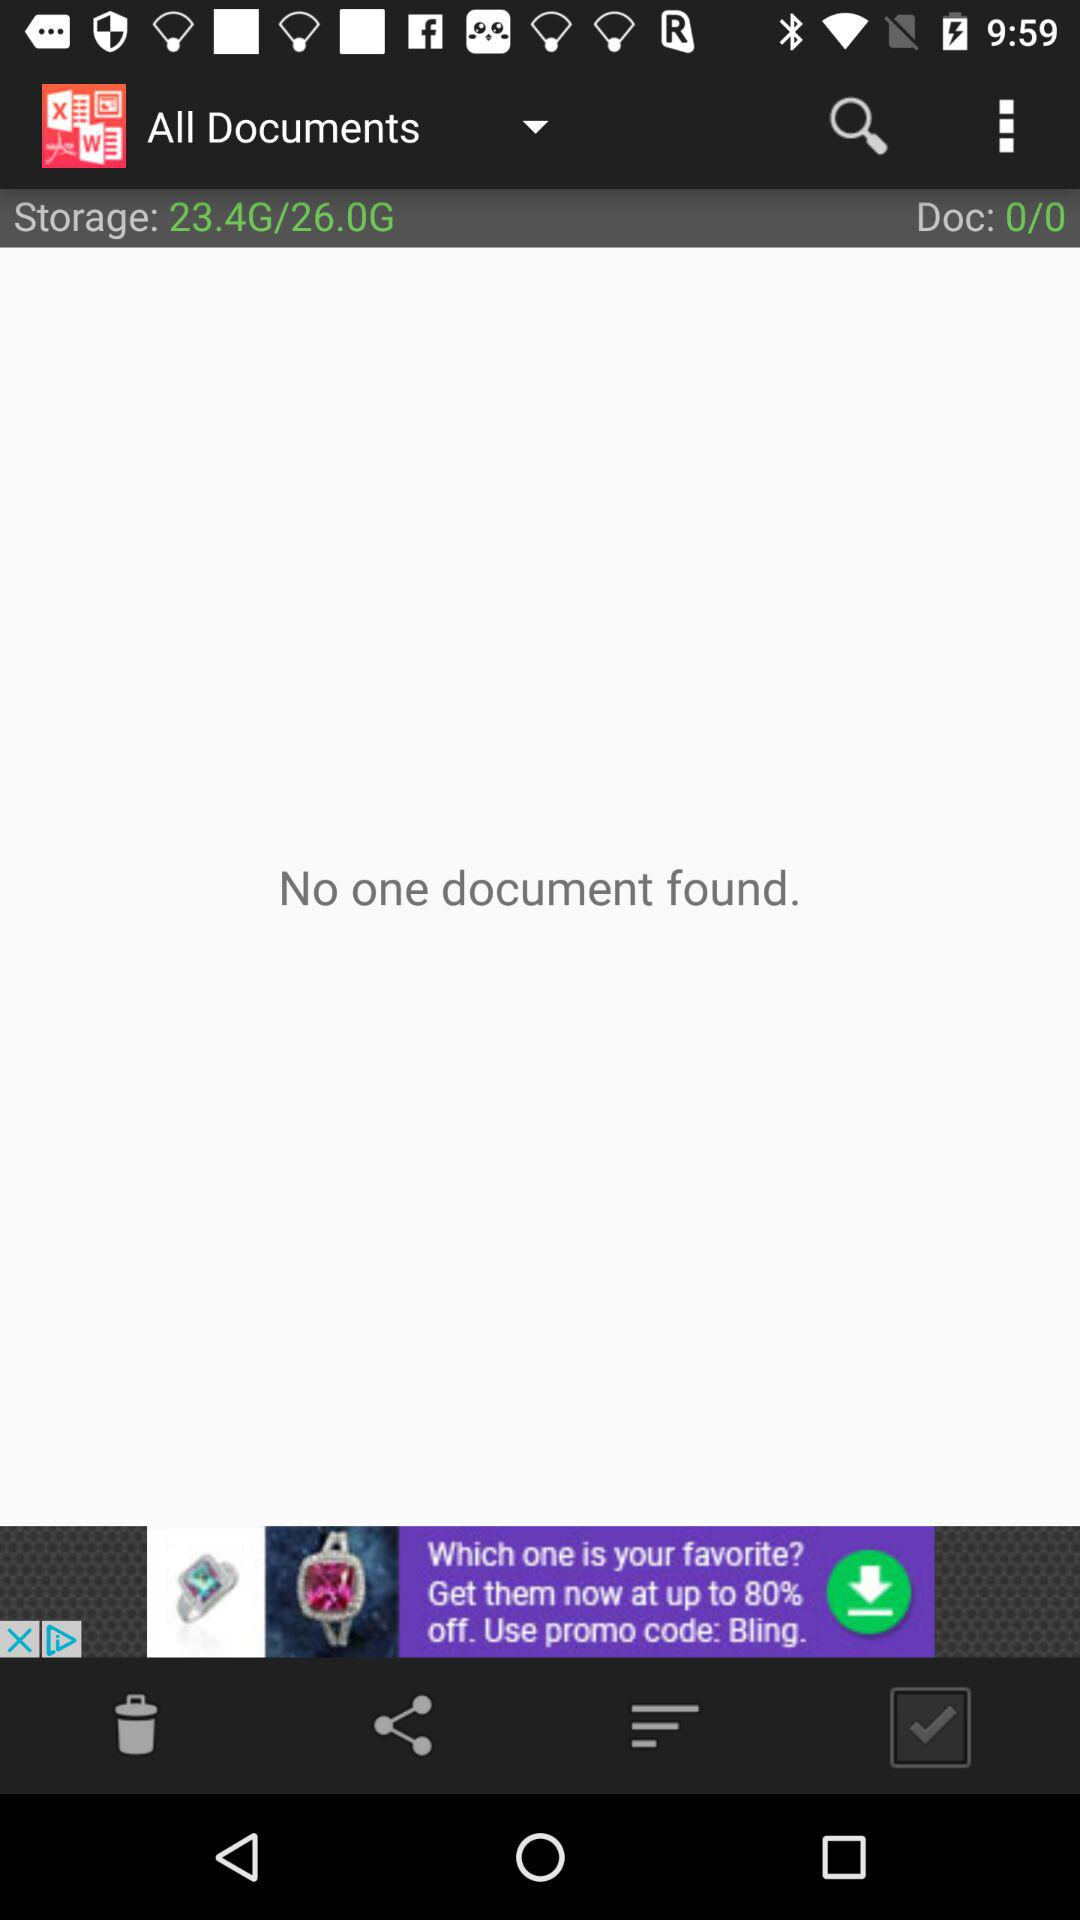What is the number of document files? The number of document files is 0. 